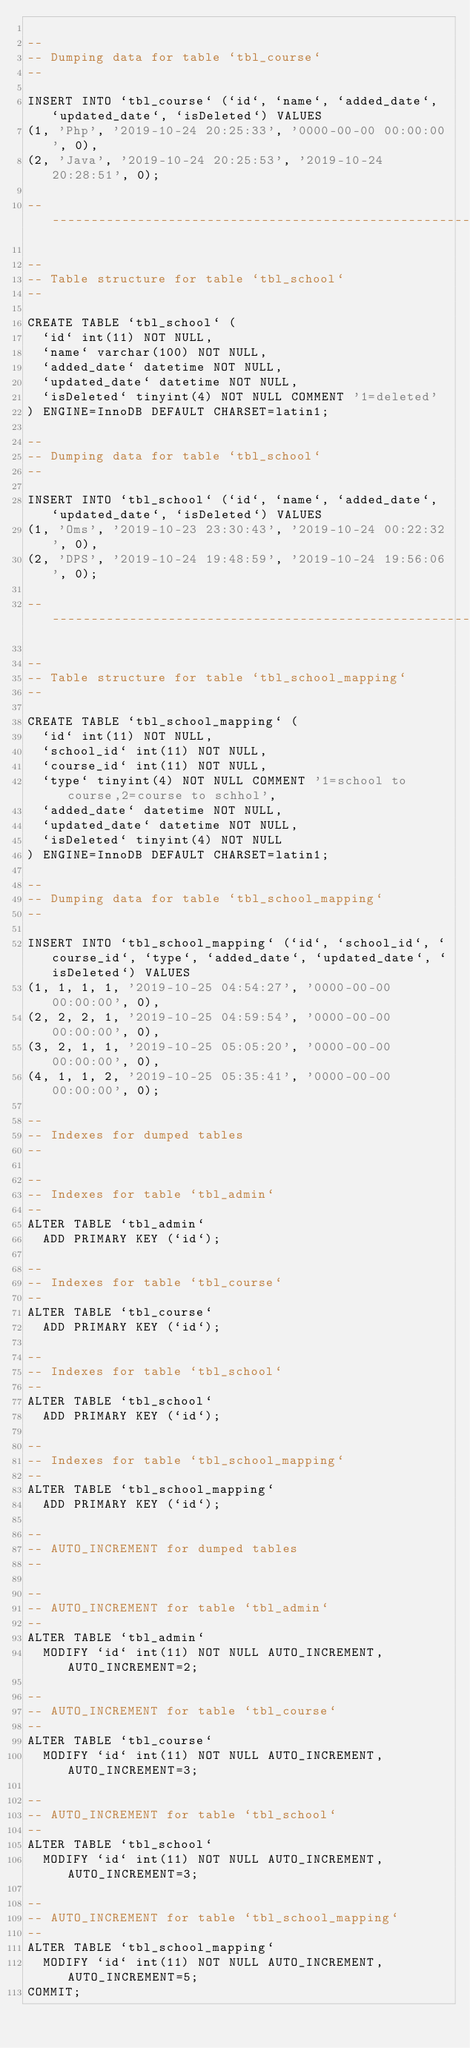Convert code to text. <code><loc_0><loc_0><loc_500><loc_500><_SQL_>
--
-- Dumping data for table `tbl_course`
--

INSERT INTO `tbl_course` (`id`, `name`, `added_date`, `updated_date`, `isDeleted`) VALUES
(1, 'Php', '2019-10-24 20:25:33', '0000-00-00 00:00:00', 0),
(2, 'Java', '2019-10-24 20:25:53', '2019-10-24 20:28:51', 0);

-- --------------------------------------------------------

--
-- Table structure for table `tbl_school`
--

CREATE TABLE `tbl_school` (
  `id` int(11) NOT NULL,
  `name` varchar(100) NOT NULL,
  `added_date` datetime NOT NULL,
  `updated_date` datetime NOT NULL,
  `isDeleted` tinyint(4) NOT NULL COMMENT '1=deleted'
) ENGINE=InnoDB DEFAULT CHARSET=latin1;

--
-- Dumping data for table `tbl_school`
--

INSERT INTO `tbl_school` (`id`, `name`, `added_date`, `updated_date`, `isDeleted`) VALUES
(1, 'Oms', '2019-10-23 23:30:43', '2019-10-24 00:22:32', 0),
(2, 'DPS', '2019-10-24 19:48:59', '2019-10-24 19:56:06', 0);

-- --------------------------------------------------------

--
-- Table structure for table `tbl_school_mapping`
--

CREATE TABLE `tbl_school_mapping` (
  `id` int(11) NOT NULL,
  `school_id` int(11) NOT NULL,
  `course_id` int(11) NOT NULL,
  `type` tinyint(4) NOT NULL COMMENT '1=school to course,2=course to schhol',
  `added_date` datetime NOT NULL,
  `updated_date` datetime NOT NULL,
  `isDeleted` tinyint(4) NOT NULL
) ENGINE=InnoDB DEFAULT CHARSET=latin1;

--
-- Dumping data for table `tbl_school_mapping`
--

INSERT INTO `tbl_school_mapping` (`id`, `school_id`, `course_id`, `type`, `added_date`, `updated_date`, `isDeleted`) VALUES
(1, 1, 1, 1, '2019-10-25 04:54:27', '0000-00-00 00:00:00', 0),
(2, 2, 2, 1, '2019-10-25 04:59:54', '0000-00-00 00:00:00', 0),
(3, 2, 1, 1, '2019-10-25 05:05:20', '0000-00-00 00:00:00', 0),
(4, 1, 1, 2, '2019-10-25 05:35:41', '0000-00-00 00:00:00', 0);

--
-- Indexes for dumped tables
--

--
-- Indexes for table `tbl_admin`
--
ALTER TABLE `tbl_admin`
  ADD PRIMARY KEY (`id`);

--
-- Indexes for table `tbl_course`
--
ALTER TABLE `tbl_course`
  ADD PRIMARY KEY (`id`);

--
-- Indexes for table `tbl_school`
--
ALTER TABLE `tbl_school`
  ADD PRIMARY KEY (`id`);

--
-- Indexes for table `tbl_school_mapping`
--
ALTER TABLE `tbl_school_mapping`
  ADD PRIMARY KEY (`id`);

--
-- AUTO_INCREMENT for dumped tables
--

--
-- AUTO_INCREMENT for table `tbl_admin`
--
ALTER TABLE `tbl_admin`
  MODIFY `id` int(11) NOT NULL AUTO_INCREMENT, AUTO_INCREMENT=2;

--
-- AUTO_INCREMENT for table `tbl_course`
--
ALTER TABLE `tbl_course`
  MODIFY `id` int(11) NOT NULL AUTO_INCREMENT, AUTO_INCREMENT=3;

--
-- AUTO_INCREMENT for table `tbl_school`
--
ALTER TABLE `tbl_school`
  MODIFY `id` int(11) NOT NULL AUTO_INCREMENT, AUTO_INCREMENT=3;

--
-- AUTO_INCREMENT for table `tbl_school_mapping`
--
ALTER TABLE `tbl_school_mapping`
  MODIFY `id` int(11) NOT NULL AUTO_INCREMENT, AUTO_INCREMENT=5;
COMMIT;
</code> 